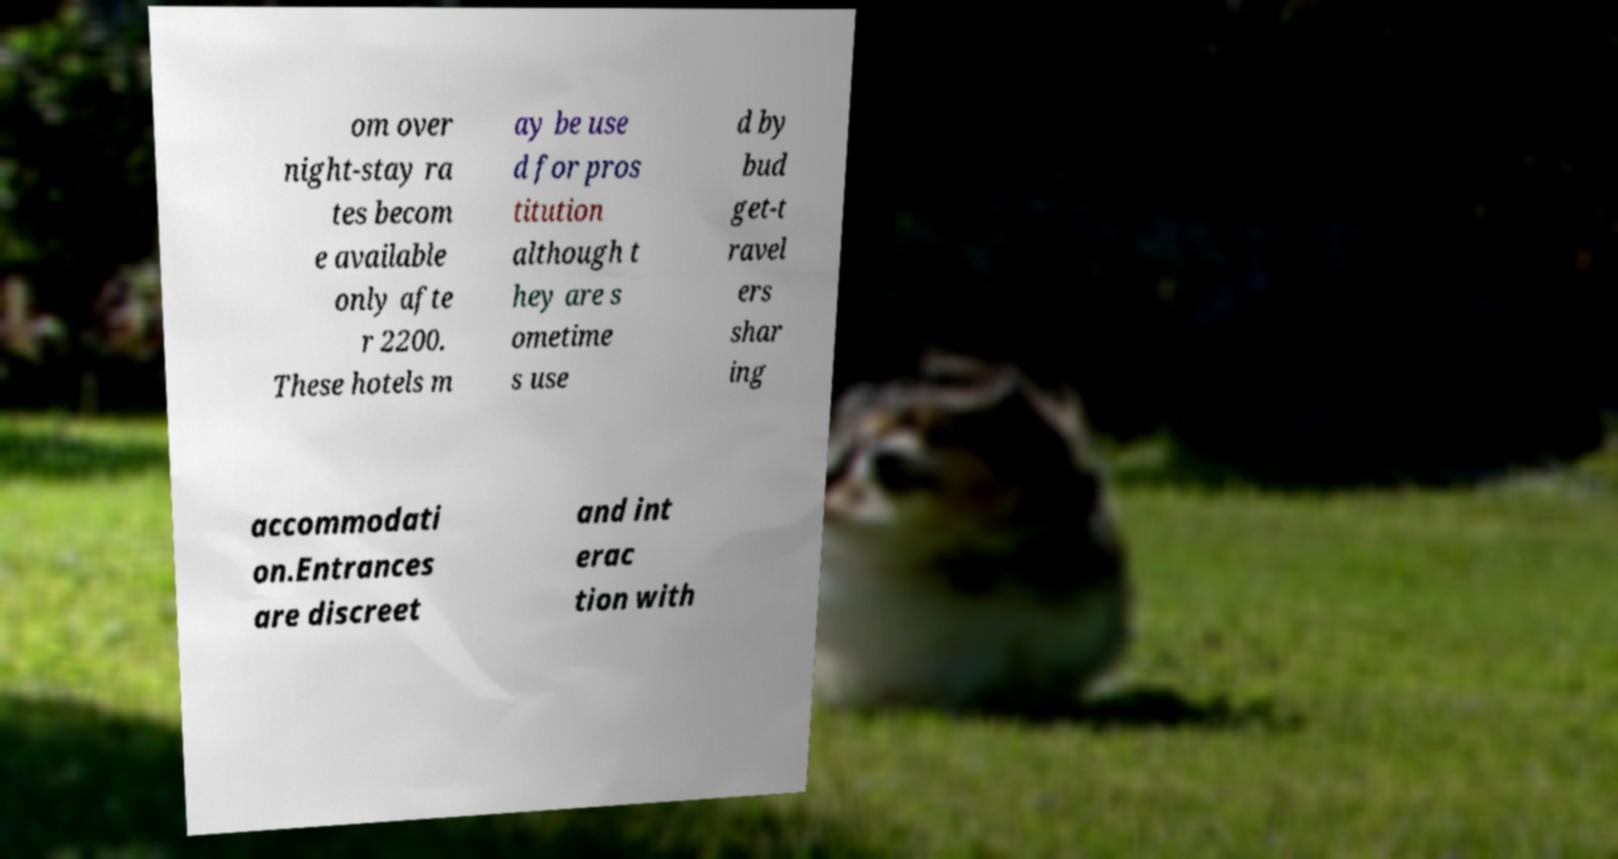Could you assist in decoding the text presented in this image and type it out clearly? om over night-stay ra tes becom e available only afte r 2200. These hotels m ay be use d for pros titution although t hey are s ometime s use d by bud get-t ravel ers shar ing accommodati on.Entrances are discreet and int erac tion with 